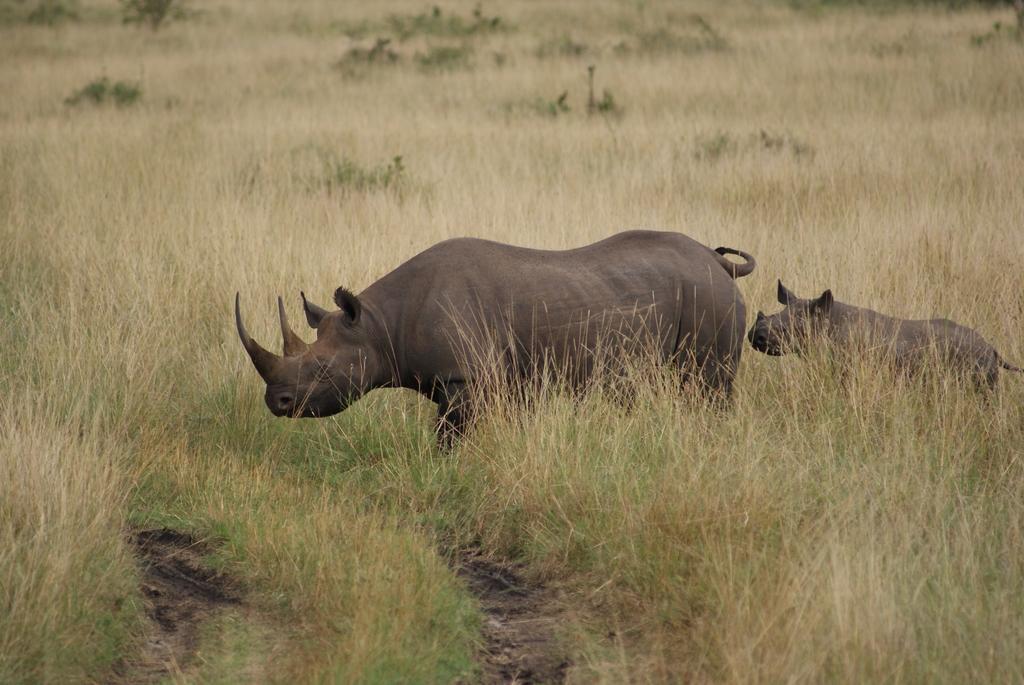Can you describe this image briefly? In this picture we can see few rhinos, plants and grass. 